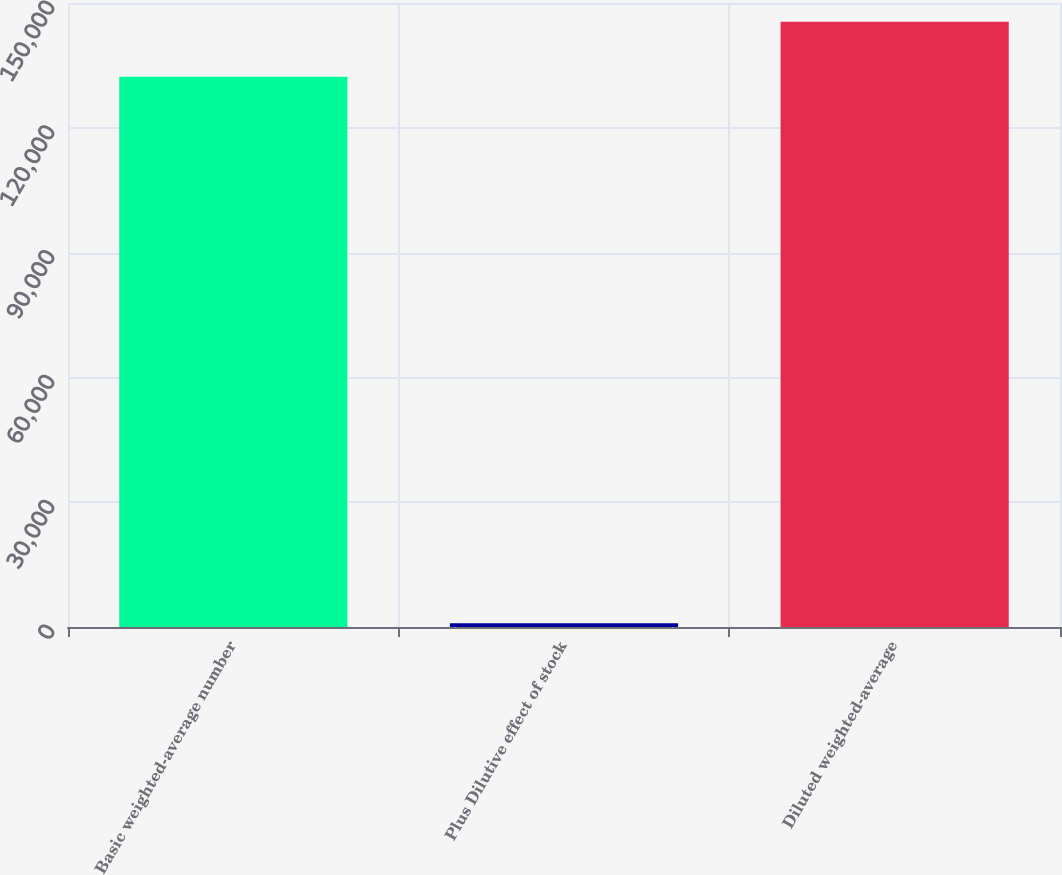Convert chart to OTSL. <chart><loc_0><loc_0><loc_500><loc_500><bar_chart><fcel>Basic weighted-average number<fcel>Plus Dilutive effect of stock<fcel>Diluted weighted-average<nl><fcel>132284<fcel>883<fcel>145512<nl></chart> 